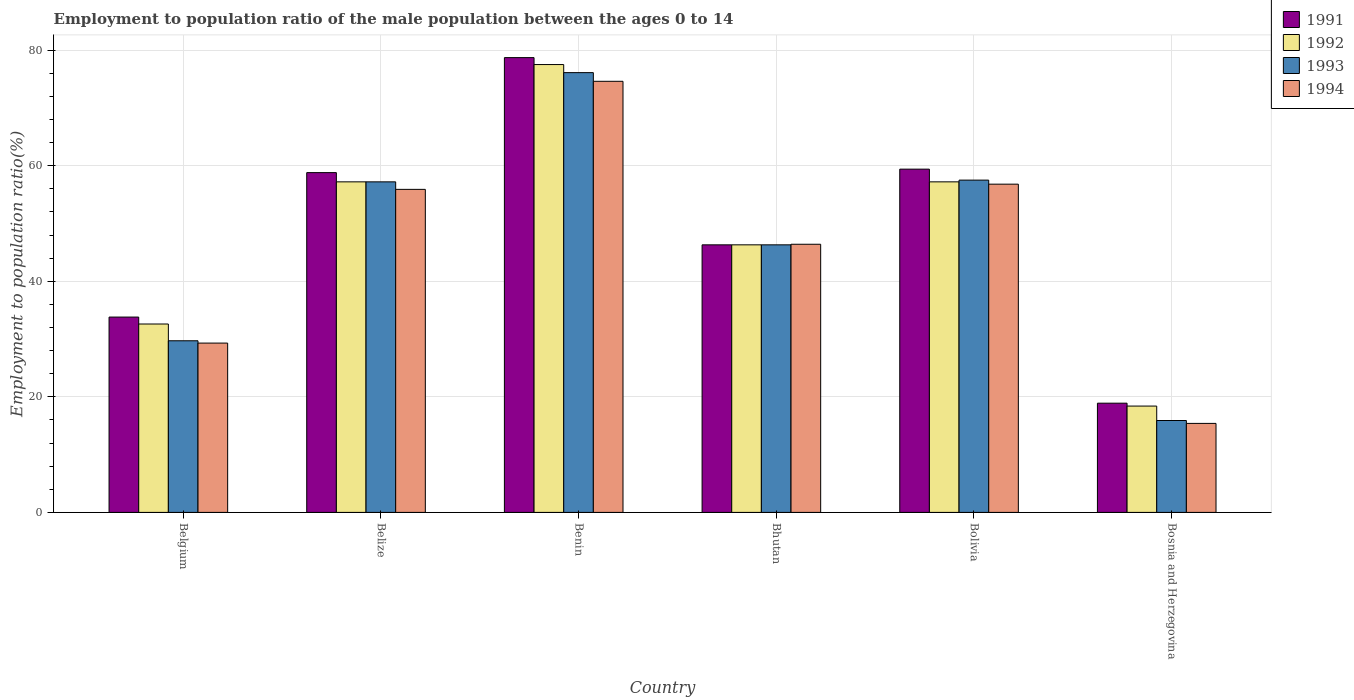How many different coloured bars are there?
Your response must be concise. 4. How many groups of bars are there?
Your response must be concise. 6. What is the label of the 2nd group of bars from the left?
Provide a short and direct response. Belize. In how many cases, is the number of bars for a given country not equal to the number of legend labels?
Your response must be concise. 0. What is the employment to population ratio in 1992 in Bhutan?
Give a very brief answer. 46.3. Across all countries, what is the maximum employment to population ratio in 1994?
Your answer should be very brief. 74.6. Across all countries, what is the minimum employment to population ratio in 1994?
Provide a succinct answer. 15.4. In which country was the employment to population ratio in 1994 maximum?
Your answer should be very brief. Benin. In which country was the employment to population ratio in 1991 minimum?
Offer a terse response. Bosnia and Herzegovina. What is the total employment to population ratio in 1992 in the graph?
Offer a terse response. 289.2. What is the difference between the employment to population ratio in 1994 in Belgium and that in Bosnia and Herzegovina?
Offer a terse response. 13.9. What is the difference between the employment to population ratio in 1991 in Bolivia and the employment to population ratio in 1994 in Bosnia and Herzegovina?
Give a very brief answer. 44. What is the average employment to population ratio in 1994 per country?
Your answer should be very brief. 46.4. What is the difference between the employment to population ratio of/in 1993 and employment to population ratio of/in 1992 in Bolivia?
Give a very brief answer. 0.3. What is the ratio of the employment to population ratio in 1991 in Benin to that in Bosnia and Herzegovina?
Your answer should be very brief. 4.16. Is the difference between the employment to population ratio in 1993 in Benin and Bosnia and Herzegovina greater than the difference between the employment to population ratio in 1992 in Benin and Bosnia and Herzegovina?
Keep it short and to the point. Yes. What is the difference between the highest and the second highest employment to population ratio in 1992?
Offer a very short reply. -20.3. What is the difference between the highest and the lowest employment to population ratio in 1994?
Give a very brief answer. 59.2. In how many countries, is the employment to population ratio in 1994 greater than the average employment to population ratio in 1994 taken over all countries?
Your answer should be compact. 4. What does the 3rd bar from the left in Bhutan represents?
Ensure brevity in your answer.  1993. What does the 4th bar from the right in Bolivia represents?
Your answer should be very brief. 1991. Are all the bars in the graph horizontal?
Ensure brevity in your answer.  No. Are the values on the major ticks of Y-axis written in scientific E-notation?
Provide a short and direct response. No. Does the graph contain any zero values?
Your answer should be compact. No. How many legend labels are there?
Give a very brief answer. 4. What is the title of the graph?
Keep it short and to the point. Employment to population ratio of the male population between the ages 0 to 14. What is the label or title of the X-axis?
Your answer should be very brief. Country. What is the Employment to population ratio(%) in 1991 in Belgium?
Your answer should be compact. 33.8. What is the Employment to population ratio(%) in 1992 in Belgium?
Offer a terse response. 32.6. What is the Employment to population ratio(%) in 1993 in Belgium?
Ensure brevity in your answer.  29.7. What is the Employment to population ratio(%) of 1994 in Belgium?
Give a very brief answer. 29.3. What is the Employment to population ratio(%) in 1991 in Belize?
Make the answer very short. 58.8. What is the Employment to population ratio(%) in 1992 in Belize?
Provide a succinct answer. 57.2. What is the Employment to population ratio(%) of 1993 in Belize?
Provide a short and direct response. 57.2. What is the Employment to population ratio(%) in 1994 in Belize?
Keep it short and to the point. 55.9. What is the Employment to population ratio(%) in 1991 in Benin?
Your answer should be compact. 78.7. What is the Employment to population ratio(%) of 1992 in Benin?
Ensure brevity in your answer.  77.5. What is the Employment to population ratio(%) in 1993 in Benin?
Your response must be concise. 76.1. What is the Employment to population ratio(%) in 1994 in Benin?
Ensure brevity in your answer.  74.6. What is the Employment to population ratio(%) in 1991 in Bhutan?
Your answer should be compact. 46.3. What is the Employment to population ratio(%) in 1992 in Bhutan?
Keep it short and to the point. 46.3. What is the Employment to population ratio(%) in 1993 in Bhutan?
Your answer should be compact. 46.3. What is the Employment to population ratio(%) of 1994 in Bhutan?
Ensure brevity in your answer.  46.4. What is the Employment to population ratio(%) of 1991 in Bolivia?
Ensure brevity in your answer.  59.4. What is the Employment to population ratio(%) of 1992 in Bolivia?
Your answer should be compact. 57.2. What is the Employment to population ratio(%) of 1993 in Bolivia?
Ensure brevity in your answer.  57.5. What is the Employment to population ratio(%) of 1994 in Bolivia?
Your answer should be compact. 56.8. What is the Employment to population ratio(%) of 1991 in Bosnia and Herzegovina?
Offer a terse response. 18.9. What is the Employment to population ratio(%) in 1992 in Bosnia and Herzegovina?
Your answer should be compact. 18.4. What is the Employment to population ratio(%) of 1993 in Bosnia and Herzegovina?
Offer a terse response. 15.9. What is the Employment to population ratio(%) of 1994 in Bosnia and Herzegovina?
Your response must be concise. 15.4. Across all countries, what is the maximum Employment to population ratio(%) of 1991?
Keep it short and to the point. 78.7. Across all countries, what is the maximum Employment to population ratio(%) of 1992?
Give a very brief answer. 77.5. Across all countries, what is the maximum Employment to population ratio(%) of 1993?
Offer a very short reply. 76.1. Across all countries, what is the maximum Employment to population ratio(%) of 1994?
Provide a succinct answer. 74.6. Across all countries, what is the minimum Employment to population ratio(%) of 1991?
Provide a succinct answer. 18.9. Across all countries, what is the minimum Employment to population ratio(%) of 1992?
Offer a very short reply. 18.4. Across all countries, what is the minimum Employment to population ratio(%) in 1993?
Give a very brief answer. 15.9. Across all countries, what is the minimum Employment to population ratio(%) of 1994?
Give a very brief answer. 15.4. What is the total Employment to population ratio(%) of 1991 in the graph?
Your response must be concise. 295.9. What is the total Employment to population ratio(%) of 1992 in the graph?
Provide a short and direct response. 289.2. What is the total Employment to population ratio(%) in 1993 in the graph?
Provide a short and direct response. 282.7. What is the total Employment to population ratio(%) in 1994 in the graph?
Offer a very short reply. 278.4. What is the difference between the Employment to population ratio(%) of 1991 in Belgium and that in Belize?
Give a very brief answer. -25. What is the difference between the Employment to population ratio(%) in 1992 in Belgium and that in Belize?
Your answer should be very brief. -24.6. What is the difference between the Employment to population ratio(%) in 1993 in Belgium and that in Belize?
Ensure brevity in your answer.  -27.5. What is the difference between the Employment to population ratio(%) of 1994 in Belgium and that in Belize?
Offer a terse response. -26.6. What is the difference between the Employment to population ratio(%) of 1991 in Belgium and that in Benin?
Make the answer very short. -44.9. What is the difference between the Employment to population ratio(%) in 1992 in Belgium and that in Benin?
Provide a short and direct response. -44.9. What is the difference between the Employment to population ratio(%) in 1993 in Belgium and that in Benin?
Keep it short and to the point. -46.4. What is the difference between the Employment to population ratio(%) of 1994 in Belgium and that in Benin?
Offer a terse response. -45.3. What is the difference between the Employment to population ratio(%) in 1991 in Belgium and that in Bhutan?
Your answer should be compact. -12.5. What is the difference between the Employment to population ratio(%) in 1992 in Belgium and that in Bhutan?
Offer a very short reply. -13.7. What is the difference between the Employment to population ratio(%) in 1993 in Belgium and that in Bhutan?
Make the answer very short. -16.6. What is the difference between the Employment to population ratio(%) in 1994 in Belgium and that in Bhutan?
Keep it short and to the point. -17.1. What is the difference between the Employment to population ratio(%) in 1991 in Belgium and that in Bolivia?
Provide a short and direct response. -25.6. What is the difference between the Employment to population ratio(%) of 1992 in Belgium and that in Bolivia?
Ensure brevity in your answer.  -24.6. What is the difference between the Employment to population ratio(%) of 1993 in Belgium and that in Bolivia?
Keep it short and to the point. -27.8. What is the difference between the Employment to population ratio(%) of 1994 in Belgium and that in Bolivia?
Keep it short and to the point. -27.5. What is the difference between the Employment to population ratio(%) in 1993 in Belgium and that in Bosnia and Herzegovina?
Provide a short and direct response. 13.8. What is the difference between the Employment to population ratio(%) in 1991 in Belize and that in Benin?
Provide a succinct answer. -19.9. What is the difference between the Employment to population ratio(%) in 1992 in Belize and that in Benin?
Provide a short and direct response. -20.3. What is the difference between the Employment to population ratio(%) of 1993 in Belize and that in Benin?
Keep it short and to the point. -18.9. What is the difference between the Employment to population ratio(%) in 1994 in Belize and that in Benin?
Give a very brief answer. -18.7. What is the difference between the Employment to population ratio(%) in 1993 in Belize and that in Bolivia?
Offer a terse response. -0.3. What is the difference between the Employment to population ratio(%) of 1994 in Belize and that in Bolivia?
Make the answer very short. -0.9. What is the difference between the Employment to population ratio(%) in 1991 in Belize and that in Bosnia and Herzegovina?
Provide a short and direct response. 39.9. What is the difference between the Employment to population ratio(%) in 1992 in Belize and that in Bosnia and Herzegovina?
Your response must be concise. 38.8. What is the difference between the Employment to population ratio(%) of 1993 in Belize and that in Bosnia and Herzegovina?
Your answer should be very brief. 41.3. What is the difference between the Employment to population ratio(%) of 1994 in Belize and that in Bosnia and Herzegovina?
Your response must be concise. 40.5. What is the difference between the Employment to population ratio(%) in 1991 in Benin and that in Bhutan?
Offer a very short reply. 32.4. What is the difference between the Employment to population ratio(%) of 1992 in Benin and that in Bhutan?
Make the answer very short. 31.2. What is the difference between the Employment to population ratio(%) of 1993 in Benin and that in Bhutan?
Offer a terse response. 29.8. What is the difference between the Employment to population ratio(%) of 1994 in Benin and that in Bhutan?
Your answer should be compact. 28.2. What is the difference between the Employment to population ratio(%) in 1991 in Benin and that in Bolivia?
Your answer should be compact. 19.3. What is the difference between the Employment to population ratio(%) in 1992 in Benin and that in Bolivia?
Your answer should be very brief. 20.3. What is the difference between the Employment to population ratio(%) of 1994 in Benin and that in Bolivia?
Offer a very short reply. 17.8. What is the difference between the Employment to population ratio(%) in 1991 in Benin and that in Bosnia and Herzegovina?
Ensure brevity in your answer.  59.8. What is the difference between the Employment to population ratio(%) of 1992 in Benin and that in Bosnia and Herzegovina?
Give a very brief answer. 59.1. What is the difference between the Employment to population ratio(%) in 1993 in Benin and that in Bosnia and Herzegovina?
Your answer should be compact. 60.2. What is the difference between the Employment to population ratio(%) in 1994 in Benin and that in Bosnia and Herzegovina?
Make the answer very short. 59.2. What is the difference between the Employment to population ratio(%) of 1992 in Bhutan and that in Bolivia?
Offer a very short reply. -10.9. What is the difference between the Employment to population ratio(%) of 1993 in Bhutan and that in Bolivia?
Offer a very short reply. -11.2. What is the difference between the Employment to population ratio(%) in 1994 in Bhutan and that in Bolivia?
Provide a succinct answer. -10.4. What is the difference between the Employment to population ratio(%) of 1991 in Bhutan and that in Bosnia and Herzegovina?
Give a very brief answer. 27.4. What is the difference between the Employment to population ratio(%) of 1992 in Bhutan and that in Bosnia and Herzegovina?
Your answer should be very brief. 27.9. What is the difference between the Employment to population ratio(%) of 1993 in Bhutan and that in Bosnia and Herzegovina?
Your answer should be very brief. 30.4. What is the difference between the Employment to population ratio(%) in 1991 in Bolivia and that in Bosnia and Herzegovina?
Offer a very short reply. 40.5. What is the difference between the Employment to population ratio(%) in 1992 in Bolivia and that in Bosnia and Herzegovina?
Provide a short and direct response. 38.8. What is the difference between the Employment to population ratio(%) in 1993 in Bolivia and that in Bosnia and Herzegovina?
Provide a succinct answer. 41.6. What is the difference between the Employment to population ratio(%) in 1994 in Bolivia and that in Bosnia and Herzegovina?
Offer a very short reply. 41.4. What is the difference between the Employment to population ratio(%) in 1991 in Belgium and the Employment to population ratio(%) in 1992 in Belize?
Provide a succinct answer. -23.4. What is the difference between the Employment to population ratio(%) of 1991 in Belgium and the Employment to population ratio(%) of 1993 in Belize?
Ensure brevity in your answer.  -23.4. What is the difference between the Employment to population ratio(%) of 1991 in Belgium and the Employment to population ratio(%) of 1994 in Belize?
Make the answer very short. -22.1. What is the difference between the Employment to population ratio(%) of 1992 in Belgium and the Employment to population ratio(%) of 1993 in Belize?
Your answer should be very brief. -24.6. What is the difference between the Employment to population ratio(%) of 1992 in Belgium and the Employment to population ratio(%) of 1994 in Belize?
Ensure brevity in your answer.  -23.3. What is the difference between the Employment to population ratio(%) in 1993 in Belgium and the Employment to population ratio(%) in 1994 in Belize?
Give a very brief answer. -26.2. What is the difference between the Employment to population ratio(%) in 1991 in Belgium and the Employment to population ratio(%) in 1992 in Benin?
Make the answer very short. -43.7. What is the difference between the Employment to population ratio(%) in 1991 in Belgium and the Employment to population ratio(%) in 1993 in Benin?
Keep it short and to the point. -42.3. What is the difference between the Employment to population ratio(%) in 1991 in Belgium and the Employment to population ratio(%) in 1994 in Benin?
Your answer should be very brief. -40.8. What is the difference between the Employment to population ratio(%) in 1992 in Belgium and the Employment to population ratio(%) in 1993 in Benin?
Offer a terse response. -43.5. What is the difference between the Employment to population ratio(%) in 1992 in Belgium and the Employment to population ratio(%) in 1994 in Benin?
Ensure brevity in your answer.  -42. What is the difference between the Employment to population ratio(%) of 1993 in Belgium and the Employment to population ratio(%) of 1994 in Benin?
Your answer should be very brief. -44.9. What is the difference between the Employment to population ratio(%) in 1991 in Belgium and the Employment to population ratio(%) in 1992 in Bhutan?
Your answer should be compact. -12.5. What is the difference between the Employment to population ratio(%) of 1991 in Belgium and the Employment to population ratio(%) of 1993 in Bhutan?
Give a very brief answer. -12.5. What is the difference between the Employment to population ratio(%) in 1991 in Belgium and the Employment to population ratio(%) in 1994 in Bhutan?
Your answer should be very brief. -12.6. What is the difference between the Employment to population ratio(%) in 1992 in Belgium and the Employment to population ratio(%) in 1993 in Bhutan?
Your answer should be compact. -13.7. What is the difference between the Employment to population ratio(%) of 1992 in Belgium and the Employment to population ratio(%) of 1994 in Bhutan?
Make the answer very short. -13.8. What is the difference between the Employment to population ratio(%) of 1993 in Belgium and the Employment to population ratio(%) of 1994 in Bhutan?
Your answer should be compact. -16.7. What is the difference between the Employment to population ratio(%) of 1991 in Belgium and the Employment to population ratio(%) of 1992 in Bolivia?
Your answer should be compact. -23.4. What is the difference between the Employment to population ratio(%) in 1991 in Belgium and the Employment to population ratio(%) in 1993 in Bolivia?
Your response must be concise. -23.7. What is the difference between the Employment to population ratio(%) of 1991 in Belgium and the Employment to population ratio(%) of 1994 in Bolivia?
Your answer should be compact. -23. What is the difference between the Employment to population ratio(%) in 1992 in Belgium and the Employment to population ratio(%) in 1993 in Bolivia?
Give a very brief answer. -24.9. What is the difference between the Employment to population ratio(%) in 1992 in Belgium and the Employment to population ratio(%) in 1994 in Bolivia?
Offer a very short reply. -24.2. What is the difference between the Employment to population ratio(%) in 1993 in Belgium and the Employment to population ratio(%) in 1994 in Bolivia?
Your answer should be very brief. -27.1. What is the difference between the Employment to population ratio(%) in 1991 in Belgium and the Employment to population ratio(%) in 1993 in Bosnia and Herzegovina?
Your response must be concise. 17.9. What is the difference between the Employment to population ratio(%) of 1992 in Belgium and the Employment to population ratio(%) of 1993 in Bosnia and Herzegovina?
Keep it short and to the point. 16.7. What is the difference between the Employment to population ratio(%) in 1991 in Belize and the Employment to population ratio(%) in 1992 in Benin?
Ensure brevity in your answer.  -18.7. What is the difference between the Employment to population ratio(%) of 1991 in Belize and the Employment to population ratio(%) of 1993 in Benin?
Your response must be concise. -17.3. What is the difference between the Employment to population ratio(%) of 1991 in Belize and the Employment to population ratio(%) of 1994 in Benin?
Provide a succinct answer. -15.8. What is the difference between the Employment to population ratio(%) in 1992 in Belize and the Employment to population ratio(%) in 1993 in Benin?
Ensure brevity in your answer.  -18.9. What is the difference between the Employment to population ratio(%) of 1992 in Belize and the Employment to population ratio(%) of 1994 in Benin?
Your response must be concise. -17.4. What is the difference between the Employment to population ratio(%) of 1993 in Belize and the Employment to population ratio(%) of 1994 in Benin?
Your answer should be very brief. -17.4. What is the difference between the Employment to population ratio(%) of 1991 in Belize and the Employment to population ratio(%) of 1994 in Bhutan?
Ensure brevity in your answer.  12.4. What is the difference between the Employment to population ratio(%) in 1992 in Belize and the Employment to population ratio(%) in 1993 in Bhutan?
Ensure brevity in your answer.  10.9. What is the difference between the Employment to population ratio(%) of 1992 in Belize and the Employment to population ratio(%) of 1994 in Bhutan?
Offer a terse response. 10.8. What is the difference between the Employment to population ratio(%) of 1991 in Belize and the Employment to population ratio(%) of 1992 in Bolivia?
Make the answer very short. 1.6. What is the difference between the Employment to population ratio(%) in 1991 in Belize and the Employment to population ratio(%) in 1993 in Bolivia?
Make the answer very short. 1.3. What is the difference between the Employment to population ratio(%) in 1991 in Belize and the Employment to population ratio(%) in 1992 in Bosnia and Herzegovina?
Your answer should be very brief. 40.4. What is the difference between the Employment to population ratio(%) of 1991 in Belize and the Employment to population ratio(%) of 1993 in Bosnia and Herzegovina?
Provide a succinct answer. 42.9. What is the difference between the Employment to population ratio(%) of 1991 in Belize and the Employment to population ratio(%) of 1994 in Bosnia and Herzegovina?
Offer a terse response. 43.4. What is the difference between the Employment to population ratio(%) in 1992 in Belize and the Employment to population ratio(%) in 1993 in Bosnia and Herzegovina?
Your response must be concise. 41.3. What is the difference between the Employment to population ratio(%) of 1992 in Belize and the Employment to population ratio(%) of 1994 in Bosnia and Herzegovina?
Keep it short and to the point. 41.8. What is the difference between the Employment to population ratio(%) in 1993 in Belize and the Employment to population ratio(%) in 1994 in Bosnia and Herzegovina?
Keep it short and to the point. 41.8. What is the difference between the Employment to population ratio(%) of 1991 in Benin and the Employment to population ratio(%) of 1992 in Bhutan?
Ensure brevity in your answer.  32.4. What is the difference between the Employment to population ratio(%) in 1991 in Benin and the Employment to population ratio(%) in 1993 in Bhutan?
Keep it short and to the point. 32.4. What is the difference between the Employment to population ratio(%) in 1991 in Benin and the Employment to population ratio(%) in 1994 in Bhutan?
Your answer should be compact. 32.3. What is the difference between the Employment to population ratio(%) of 1992 in Benin and the Employment to population ratio(%) of 1993 in Bhutan?
Your answer should be compact. 31.2. What is the difference between the Employment to population ratio(%) of 1992 in Benin and the Employment to population ratio(%) of 1994 in Bhutan?
Offer a very short reply. 31.1. What is the difference between the Employment to population ratio(%) of 1993 in Benin and the Employment to population ratio(%) of 1994 in Bhutan?
Provide a succinct answer. 29.7. What is the difference between the Employment to population ratio(%) of 1991 in Benin and the Employment to population ratio(%) of 1993 in Bolivia?
Offer a very short reply. 21.2. What is the difference between the Employment to population ratio(%) of 1991 in Benin and the Employment to population ratio(%) of 1994 in Bolivia?
Provide a short and direct response. 21.9. What is the difference between the Employment to population ratio(%) of 1992 in Benin and the Employment to population ratio(%) of 1994 in Bolivia?
Offer a very short reply. 20.7. What is the difference between the Employment to population ratio(%) of 1993 in Benin and the Employment to population ratio(%) of 1994 in Bolivia?
Your response must be concise. 19.3. What is the difference between the Employment to population ratio(%) in 1991 in Benin and the Employment to population ratio(%) in 1992 in Bosnia and Herzegovina?
Offer a very short reply. 60.3. What is the difference between the Employment to population ratio(%) in 1991 in Benin and the Employment to population ratio(%) in 1993 in Bosnia and Herzegovina?
Offer a terse response. 62.8. What is the difference between the Employment to population ratio(%) of 1991 in Benin and the Employment to population ratio(%) of 1994 in Bosnia and Herzegovina?
Your response must be concise. 63.3. What is the difference between the Employment to population ratio(%) in 1992 in Benin and the Employment to population ratio(%) in 1993 in Bosnia and Herzegovina?
Give a very brief answer. 61.6. What is the difference between the Employment to population ratio(%) of 1992 in Benin and the Employment to population ratio(%) of 1994 in Bosnia and Herzegovina?
Provide a short and direct response. 62.1. What is the difference between the Employment to population ratio(%) in 1993 in Benin and the Employment to population ratio(%) in 1994 in Bosnia and Herzegovina?
Your answer should be compact. 60.7. What is the difference between the Employment to population ratio(%) in 1991 in Bhutan and the Employment to population ratio(%) in 1994 in Bolivia?
Ensure brevity in your answer.  -10.5. What is the difference between the Employment to population ratio(%) in 1992 in Bhutan and the Employment to population ratio(%) in 1993 in Bolivia?
Offer a terse response. -11.2. What is the difference between the Employment to population ratio(%) of 1993 in Bhutan and the Employment to population ratio(%) of 1994 in Bolivia?
Your answer should be compact. -10.5. What is the difference between the Employment to population ratio(%) in 1991 in Bhutan and the Employment to population ratio(%) in 1992 in Bosnia and Herzegovina?
Ensure brevity in your answer.  27.9. What is the difference between the Employment to population ratio(%) of 1991 in Bhutan and the Employment to population ratio(%) of 1993 in Bosnia and Herzegovina?
Provide a short and direct response. 30.4. What is the difference between the Employment to population ratio(%) of 1991 in Bhutan and the Employment to population ratio(%) of 1994 in Bosnia and Herzegovina?
Your answer should be very brief. 30.9. What is the difference between the Employment to population ratio(%) in 1992 in Bhutan and the Employment to population ratio(%) in 1993 in Bosnia and Herzegovina?
Offer a very short reply. 30.4. What is the difference between the Employment to population ratio(%) of 1992 in Bhutan and the Employment to population ratio(%) of 1994 in Bosnia and Herzegovina?
Provide a succinct answer. 30.9. What is the difference between the Employment to population ratio(%) of 1993 in Bhutan and the Employment to population ratio(%) of 1994 in Bosnia and Herzegovina?
Offer a very short reply. 30.9. What is the difference between the Employment to population ratio(%) of 1991 in Bolivia and the Employment to population ratio(%) of 1992 in Bosnia and Herzegovina?
Make the answer very short. 41. What is the difference between the Employment to population ratio(%) of 1991 in Bolivia and the Employment to population ratio(%) of 1993 in Bosnia and Herzegovina?
Provide a short and direct response. 43.5. What is the difference between the Employment to population ratio(%) of 1992 in Bolivia and the Employment to population ratio(%) of 1993 in Bosnia and Herzegovina?
Give a very brief answer. 41.3. What is the difference between the Employment to population ratio(%) of 1992 in Bolivia and the Employment to population ratio(%) of 1994 in Bosnia and Herzegovina?
Offer a very short reply. 41.8. What is the difference between the Employment to population ratio(%) of 1993 in Bolivia and the Employment to population ratio(%) of 1994 in Bosnia and Herzegovina?
Provide a short and direct response. 42.1. What is the average Employment to population ratio(%) in 1991 per country?
Provide a short and direct response. 49.32. What is the average Employment to population ratio(%) in 1992 per country?
Your answer should be compact. 48.2. What is the average Employment to population ratio(%) of 1993 per country?
Provide a succinct answer. 47.12. What is the average Employment to population ratio(%) of 1994 per country?
Your response must be concise. 46.4. What is the difference between the Employment to population ratio(%) in 1991 and Employment to population ratio(%) in 1993 in Belgium?
Your answer should be compact. 4.1. What is the difference between the Employment to population ratio(%) in 1991 and Employment to population ratio(%) in 1994 in Belgium?
Offer a very short reply. 4.5. What is the difference between the Employment to population ratio(%) in 1993 and Employment to population ratio(%) in 1994 in Belgium?
Your answer should be compact. 0.4. What is the difference between the Employment to population ratio(%) of 1991 and Employment to population ratio(%) of 1993 in Belize?
Your answer should be very brief. 1.6. What is the difference between the Employment to population ratio(%) of 1991 and Employment to population ratio(%) of 1994 in Belize?
Make the answer very short. 2.9. What is the difference between the Employment to population ratio(%) in 1992 and Employment to population ratio(%) in 1993 in Belize?
Your answer should be very brief. 0. What is the difference between the Employment to population ratio(%) of 1993 and Employment to population ratio(%) of 1994 in Belize?
Offer a terse response. 1.3. What is the difference between the Employment to population ratio(%) in 1991 and Employment to population ratio(%) in 1992 in Benin?
Your response must be concise. 1.2. What is the difference between the Employment to population ratio(%) in 1992 and Employment to population ratio(%) in 1993 in Benin?
Make the answer very short. 1.4. What is the difference between the Employment to population ratio(%) of 1992 and Employment to population ratio(%) of 1994 in Benin?
Offer a terse response. 2.9. What is the difference between the Employment to population ratio(%) in 1993 and Employment to population ratio(%) in 1994 in Benin?
Offer a very short reply. 1.5. What is the difference between the Employment to population ratio(%) in 1991 and Employment to population ratio(%) in 1992 in Bhutan?
Provide a succinct answer. 0. What is the difference between the Employment to population ratio(%) of 1992 and Employment to population ratio(%) of 1993 in Bhutan?
Keep it short and to the point. 0. What is the difference between the Employment to population ratio(%) in 1992 and Employment to population ratio(%) in 1994 in Bhutan?
Provide a short and direct response. -0.1. What is the difference between the Employment to population ratio(%) in 1993 and Employment to population ratio(%) in 1994 in Bhutan?
Your answer should be compact. -0.1. What is the difference between the Employment to population ratio(%) of 1993 and Employment to population ratio(%) of 1994 in Bolivia?
Give a very brief answer. 0.7. What is the difference between the Employment to population ratio(%) of 1991 and Employment to population ratio(%) of 1992 in Bosnia and Herzegovina?
Provide a succinct answer. 0.5. What is the difference between the Employment to population ratio(%) in 1991 and Employment to population ratio(%) in 1993 in Bosnia and Herzegovina?
Provide a short and direct response. 3. What is the difference between the Employment to population ratio(%) in 1991 and Employment to population ratio(%) in 1994 in Bosnia and Herzegovina?
Provide a short and direct response. 3.5. What is the difference between the Employment to population ratio(%) in 1993 and Employment to population ratio(%) in 1994 in Bosnia and Herzegovina?
Offer a very short reply. 0.5. What is the ratio of the Employment to population ratio(%) in 1991 in Belgium to that in Belize?
Make the answer very short. 0.57. What is the ratio of the Employment to population ratio(%) of 1992 in Belgium to that in Belize?
Give a very brief answer. 0.57. What is the ratio of the Employment to population ratio(%) in 1993 in Belgium to that in Belize?
Provide a succinct answer. 0.52. What is the ratio of the Employment to population ratio(%) of 1994 in Belgium to that in Belize?
Offer a terse response. 0.52. What is the ratio of the Employment to population ratio(%) of 1991 in Belgium to that in Benin?
Keep it short and to the point. 0.43. What is the ratio of the Employment to population ratio(%) in 1992 in Belgium to that in Benin?
Ensure brevity in your answer.  0.42. What is the ratio of the Employment to population ratio(%) in 1993 in Belgium to that in Benin?
Your answer should be very brief. 0.39. What is the ratio of the Employment to population ratio(%) in 1994 in Belgium to that in Benin?
Provide a short and direct response. 0.39. What is the ratio of the Employment to population ratio(%) in 1991 in Belgium to that in Bhutan?
Your answer should be compact. 0.73. What is the ratio of the Employment to population ratio(%) in 1992 in Belgium to that in Bhutan?
Your answer should be very brief. 0.7. What is the ratio of the Employment to population ratio(%) of 1993 in Belgium to that in Bhutan?
Your answer should be compact. 0.64. What is the ratio of the Employment to population ratio(%) of 1994 in Belgium to that in Bhutan?
Your response must be concise. 0.63. What is the ratio of the Employment to population ratio(%) of 1991 in Belgium to that in Bolivia?
Your answer should be compact. 0.57. What is the ratio of the Employment to population ratio(%) of 1992 in Belgium to that in Bolivia?
Your answer should be very brief. 0.57. What is the ratio of the Employment to population ratio(%) in 1993 in Belgium to that in Bolivia?
Offer a very short reply. 0.52. What is the ratio of the Employment to population ratio(%) in 1994 in Belgium to that in Bolivia?
Provide a short and direct response. 0.52. What is the ratio of the Employment to population ratio(%) in 1991 in Belgium to that in Bosnia and Herzegovina?
Ensure brevity in your answer.  1.79. What is the ratio of the Employment to population ratio(%) of 1992 in Belgium to that in Bosnia and Herzegovina?
Offer a terse response. 1.77. What is the ratio of the Employment to population ratio(%) of 1993 in Belgium to that in Bosnia and Herzegovina?
Offer a terse response. 1.87. What is the ratio of the Employment to population ratio(%) of 1994 in Belgium to that in Bosnia and Herzegovina?
Offer a very short reply. 1.9. What is the ratio of the Employment to population ratio(%) in 1991 in Belize to that in Benin?
Provide a short and direct response. 0.75. What is the ratio of the Employment to population ratio(%) of 1992 in Belize to that in Benin?
Offer a terse response. 0.74. What is the ratio of the Employment to population ratio(%) in 1993 in Belize to that in Benin?
Make the answer very short. 0.75. What is the ratio of the Employment to population ratio(%) in 1994 in Belize to that in Benin?
Provide a succinct answer. 0.75. What is the ratio of the Employment to population ratio(%) in 1991 in Belize to that in Bhutan?
Ensure brevity in your answer.  1.27. What is the ratio of the Employment to population ratio(%) of 1992 in Belize to that in Bhutan?
Keep it short and to the point. 1.24. What is the ratio of the Employment to population ratio(%) of 1993 in Belize to that in Bhutan?
Provide a short and direct response. 1.24. What is the ratio of the Employment to population ratio(%) in 1994 in Belize to that in Bhutan?
Your answer should be compact. 1.2. What is the ratio of the Employment to population ratio(%) in 1991 in Belize to that in Bolivia?
Offer a very short reply. 0.99. What is the ratio of the Employment to population ratio(%) of 1992 in Belize to that in Bolivia?
Give a very brief answer. 1. What is the ratio of the Employment to population ratio(%) of 1993 in Belize to that in Bolivia?
Make the answer very short. 0.99. What is the ratio of the Employment to population ratio(%) of 1994 in Belize to that in Bolivia?
Your answer should be very brief. 0.98. What is the ratio of the Employment to population ratio(%) in 1991 in Belize to that in Bosnia and Herzegovina?
Ensure brevity in your answer.  3.11. What is the ratio of the Employment to population ratio(%) of 1992 in Belize to that in Bosnia and Herzegovina?
Ensure brevity in your answer.  3.11. What is the ratio of the Employment to population ratio(%) in 1993 in Belize to that in Bosnia and Herzegovina?
Provide a succinct answer. 3.6. What is the ratio of the Employment to population ratio(%) of 1994 in Belize to that in Bosnia and Herzegovina?
Provide a succinct answer. 3.63. What is the ratio of the Employment to population ratio(%) of 1991 in Benin to that in Bhutan?
Provide a short and direct response. 1.7. What is the ratio of the Employment to population ratio(%) of 1992 in Benin to that in Bhutan?
Your answer should be compact. 1.67. What is the ratio of the Employment to population ratio(%) in 1993 in Benin to that in Bhutan?
Make the answer very short. 1.64. What is the ratio of the Employment to population ratio(%) in 1994 in Benin to that in Bhutan?
Your response must be concise. 1.61. What is the ratio of the Employment to population ratio(%) in 1991 in Benin to that in Bolivia?
Ensure brevity in your answer.  1.32. What is the ratio of the Employment to population ratio(%) of 1992 in Benin to that in Bolivia?
Your answer should be compact. 1.35. What is the ratio of the Employment to population ratio(%) of 1993 in Benin to that in Bolivia?
Offer a very short reply. 1.32. What is the ratio of the Employment to population ratio(%) of 1994 in Benin to that in Bolivia?
Offer a very short reply. 1.31. What is the ratio of the Employment to population ratio(%) in 1991 in Benin to that in Bosnia and Herzegovina?
Ensure brevity in your answer.  4.16. What is the ratio of the Employment to population ratio(%) in 1992 in Benin to that in Bosnia and Herzegovina?
Your response must be concise. 4.21. What is the ratio of the Employment to population ratio(%) of 1993 in Benin to that in Bosnia and Herzegovina?
Provide a succinct answer. 4.79. What is the ratio of the Employment to population ratio(%) in 1994 in Benin to that in Bosnia and Herzegovina?
Offer a terse response. 4.84. What is the ratio of the Employment to population ratio(%) of 1991 in Bhutan to that in Bolivia?
Offer a very short reply. 0.78. What is the ratio of the Employment to population ratio(%) of 1992 in Bhutan to that in Bolivia?
Provide a succinct answer. 0.81. What is the ratio of the Employment to population ratio(%) in 1993 in Bhutan to that in Bolivia?
Provide a short and direct response. 0.81. What is the ratio of the Employment to population ratio(%) of 1994 in Bhutan to that in Bolivia?
Keep it short and to the point. 0.82. What is the ratio of the Employment to population ratio(%) in 1991 in Bhutan to that in Bosnia and Herzegovina?
Your response must be concise. 2.45. What is the ratio of the Employment to population ratio(%) in 1992 in Bhutan to that in Bosnia and Herzegovina?
Your response must be concise. 2.52. What is the ratio of the Employment to population ratio(%) in 1993 in Bhutan to that in Bosnia and Herzegovina?
Ensure brevity in your answer.  2.91. What is the ratio of the Employment to population ratio(%) of 1994 in Bhutan to that in Bosnia and Herzegovina?
Make the answer very short. 3.01. What is the ratio of the Employment to population ratio(%) in 1991 in Bolivia to that in Bosnia and Herzegovina?
Keep it short and to the point. 3.14. What is the ratio of the Employment to population ratio(%) of 1992 in Bolivia to that in Bosnia and Herzegovina?
Make the answer very short. 3.11. What is the ratio of the Employment to population ratio(%) of 1993 in Bolivia to that in Bosnia and Herzegovina?
Provide a short and direct response. 3.62. What is the ratio of the Employment to population ratio(%) in 1994 in Bolivia to that in Bosnia and Herzegovina?
Provide a succinct answer. 3.69. What is the difference between the highest and the second highest Employment to population ratio(%) of 1991?
Make the answer very short. 19.3. What is the difference between the highest and the second highest Employment to population ratio(%) of 1992?
Offer a terse response. 20.3. What is the difference between the highest and the lowest Employment to population ratio(%) in 1991?
Give a very brief answer. 59.8. What is the difference between the highest and the lowest Employment to population ratio(%) in 1992?
Offer a terse response. 59.1. What is the difference between the highest and the lowest Employment to population ratio(%) of 1993?
Your response must be concise. 60.2. What is the difference between the highest and the lowest Employment to population ratio(%) of 1994?
Make the answer very short. 59.2. 